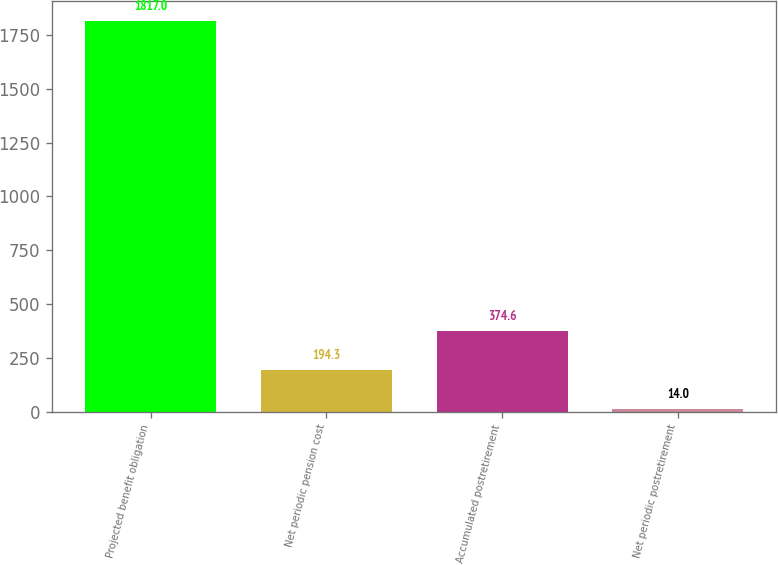<chart> <loc_0><loc_0><loc_500><loc_500><bar_chart><fcel>Projected benefit obligation<fcel>Net periodic pension cost<fcel>Accumulated postretirement<fcel>Net periodic postretirement<nl><fcel>1817<fcel>194.3<fcel>374.6<fcel>14<nl></chart> 